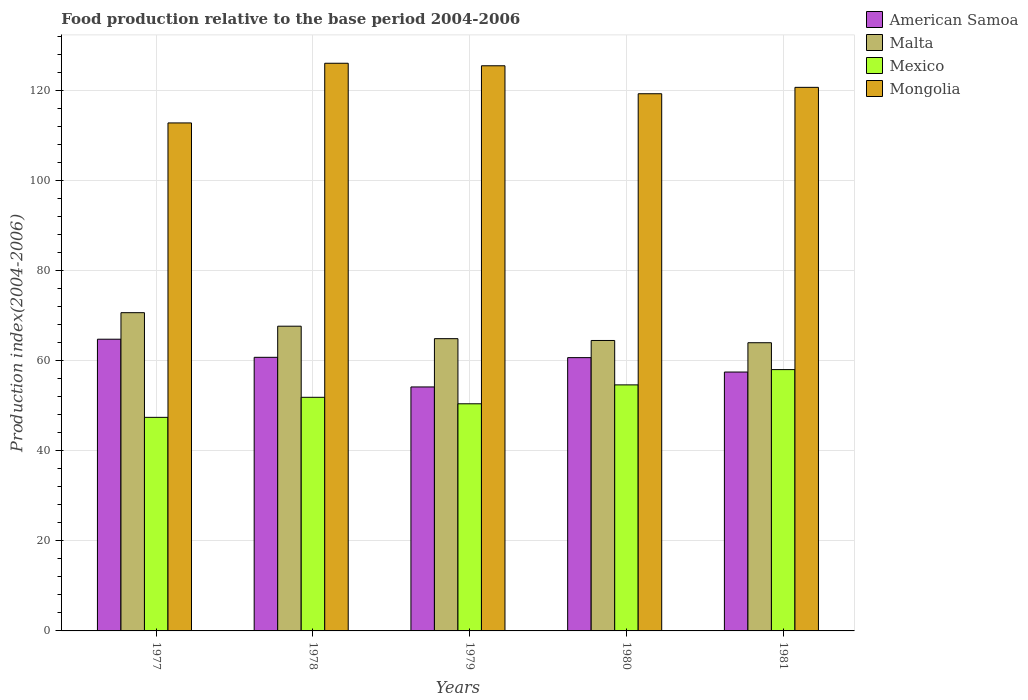How many different coloured bars are there?
Ensure brevity in your answer.  4. How many bars are there on the 2nd tick from the right?
Offer a very short reply. 4. In how many cases, is the number of bars for a given year not equal to the number of legend labels?
Ensure brevity in your answer.  0. What is the food production index in Mongolia in 1977?
Offer a terse response. 112.79. Across all years, what is the maximum food production index in Mexico?
Keep it short and to the point. 58.02. Across all years, what is the minimum food production index in Malta?
Provide a short and direct response. 63.99. In which year was the food production index in American Samoa maximum?
Your answer should be very brief. 1977. What is the total food production index in American Samoa in the graph?
Give a very brief answer. 297.85. What is the difference between the food production index in Mexico in 1977 and that in 1981?
Offer a terse response. -10.6. What is the difference between the food production index in Mexico in 1977 and the food production index in American Samoa in 1978?
Provide a succinct answer. -13.33. What is the average food production index in Mongolia per year?
Your answer should be compact. 120.85. In the year 1980, what is the difference between the food production index in Mexico and food production index in Malta?
Your answer should be compact. -9.86. What is the ratio of the food production index in American Samoa in 1979 to that in 1981?
Your response must be concise. 0.94. Is the difference between the food production index in Mexico in 1977 and 1980 greater than the difference between the food production index in Malta in 1977 and 1980?
Offer a terse response. No. What is the difference between the highest and the second highest food production index in American Samoa?
Your answer should be very brief. 4.02. What is the difference between the highest and the lowest food production index in Mexico?
Ensure brevity in your answer.  10.6. Is the sum of the food production index in Mongolia in 1978 and 1980 greater than the maximum food production index in American Samoa across all years?
Your response must be concise. Yes. Is it the case that in every year, the sum of the food production index in Mongolia and food production index in Mexico is greater than the sum of food production index in American Samoa and food production index in Malta?
Provide a succinct answer. Yes. What does the 1st bar from the left in 1980 represents?
Your response must be concise. American Samoa. What does the 4th bar from the right in 1979 represents?
Ensure brevity in your answer.  American Samoa. Is it the case that in every year, the sum of the food production index in American Samoa and food production index in Malta is greater than the food production index in Mongolia?
Ensure brevity in your answer.  No. How many bars are there?
Your response must be concise. 20. Are all the bars in the graph horizontal?
Provide a succinct answer. No. Are the values on the major ticks of Y-axis written in scientific E-notation?
Your answer should be compact. No. Does the graph contain grids?
Provide a short and direct response. Yes. Where does the legend appear in the graph?
Make the answer very short. Top right. How are the legend labels stacked?
Offer a very short reply. Vertical. What is the title of the graph?
Provide a succinct answer. Food production relative to the base period 2004-2006. What is the label or title of the Y-axis?
Give a very brief answer. Production index(2004-2006). What is the Production index(2004-2006) in American Samoa in 1977?
Make the answer very short. 64.77. What is the Production index(2004-2006) of Malta in 1977?
Provide a succinct answer. 70.66. What is the Production index(2004-2006) in Mexico in 1977?
Your response must be concise. 47.42. What is the Production index(2004-2006) of Mongolia in 1977?
Give a very brief answer. 112.79. What is the Production index(2004-2006) in American Samoa in 1978?
Your answer should be very brief. 60.75. What is the Production index(2004-2006) of Malta in 1978?
Your answer should be very brief. 67.66. What is the Production index(2004-2006) in Mexico in 1978?
Your answer should be compact. 51.87. What is the Production index(2004-2006) in Mongolia in 1978?
Offer a terse response. 126.04. What is the Production index(2004-2006) in American Samoa in 1979?
Your answer should be very brief. 54.17. What is the Production index(2004-2006) in Malta in 1979?
Keep it short and to the point. 64.89. What is the Production index(2004-2006) of Mexico in 1979?
Make the answer very short. 50.43. What is the Production index(2004-2006) of Mongolia in 1979?
Your answer should be very brief. 125.48. What is the Production index(2004-2006) in American Samoa in 1980?
Your response must be concise. 60.68. What is the Production index(2004-2006) in Malta in 1980?
Offer a terse response. 64.49. What is the Production index(2004-2006) in Mexico in 1980?
Your answer should be very brief. 54.63. What is the Production index(2004-2006) in Mongolia in 1980?
Offer a very short reply. 119.27. What is the Production index(2004-2006) of American Samoa in 1981?
Keep it short and to the point. 57.48. What is the Production index(2004-2006) of Malta in 1981?
Keep it short and to the point. 63.99. What is the Production index(2004-2006) in Mexico in 1981?
Offer a very short reply. 58.02. What is the Production index(2004-2006) in Mongolia in 1981?
Give a very brief answer. 120.69. Across all years, what is the maximum Production index(2004-2006) of American Samoa?
Your answer should be compact. 64.77. Across all years, what is the maximum Production index(2004-2006) of Malta?
Make the answer very short. 70.66. Across all years, what is the maximum Production index(2004-2006) of Mexico?
Make the answer very short. 58.02. Across all years, what is the maximum Production index(2004-2006) in Mongolia?
Provide a succinct answer. 126.04. Across all years, what is the minimum Production index(2004-2006) in American Samoa?
Your answer should be compact. 54.17. Across all years, what is the minimum Production index(2004-2006) in Malta?
Keep it short and to the point. 63.99. Across all years, what is the minimum Production index(2004-2006) of Mexico?
Offer a terse response. 47.42. Across all years, what is the minimum Production index(2004-2006) in Mongolia?
Give a very brief answer. 112.79. What is the total Production index(2004-2006) in American Samoa in the graph?
Ensure brevity in your answer.  297.85. What is the total Production index(2004-2006) of Malta in the graph?
Give a very brief answer. 331.69. What is the total Production index(2004-2006) of Mexico in the graph?
Your answer should be very brief. 262.37. What is the total Production index(2004-2006) of Mongolia in the graph?
Your answer should be compact. 604.27. What is the difference between the Production index(2004-2006) in American Samoa in 1977 and that in 1978?
Your answer should be compact. 4.02. What is the difference between the Production index(2004-2006) in Malta in 1977 and that in 1978?
Provide a succinct answer. 3. What is the difference between the Production index(2004-2006) in Mexico in 1977 and that in 1978?
Keep it short and to the point. -4.45. What is the difference between the Production index(2004-2006) in Mongolia in 1977 and that in 1978?
Your answer should be very brief. -13.25. What is the difference between the Production index(2004-2006) of Malta in 1977 and that in 1979?
Offer a very short reply. 5.77. What is the difference between the Production index(2004-2006) in Mexico in 1977 and that in 1979?
Your response must be concise. -3.01. What is the difference between the Production index(2004-2006) of Mongolia in 1977 and that in 1979?
Make the answer very short. -12.69. What is the difference between the Production index(2004-2006) of American Samoa in 1977 and that in 1980?
Give a very brief answer. 4.09. What is the difference between the Production index(2004-2006) in Malta in 1977 and that in 1980?
Offer a very short reply. 6.17. What is the difference between the Production index(2004-2006) in Mexico in 1977 and that in 1980?
Provide a succinct answer. -7.21. What is the difference between the Production index(2004-2006) of Mongolia in 1977 and that in 1980?
Ensure brevity in your answer.  -6.48. What is the difference between the Production index(2004-2006) of American Samoa in 1977 and that in 1981?
Offer a very short reply. 7.29. What is the difference between the Production index(2004-2006) in Malta in 1977 and that in 1981?
Ensure brevity in your answer.  6.67. What is the difference between the Production index(2004-2006) in Mongolia in 1977 and that in 1981?
Your answer should be compact. -7.9. What is the difference between the Production index(2004-2006) in American Samoa in 1978 and that in 1979?
Offer a terse response. 6.58. What is the difference between the Production index(2004-2006) of Malta in 1978 and that in 1979?
Give a very brief answer. 2.77. What is the difference between the Production index(2004-2006) in Mexico in 1978 and that in 1979?
Provide a short and direct response. 1.44. What is the difference between the Production index(2004-2006) of Mongolia in 1978 and that in 1979?
Provide a succinct answer. 0.56. What is the difference between the Production index(2004-2006) in American Samoa in 1978 and that in 1980?
Make the answer very short. 0.07. What is the difference between the Production index(2004-2006) in Malta in 1978 and that in 1980?
Ensure brevity in your answer.  3.17. What is the difference between the Production index(2004-2006) of Mexico in 1978 and that in 1980?
Provide a succinct answer. -2.76. What is the difference between the Production index(2004-2006) in Mongolia in 1978 and that in 1980?
Provide a succinct answer. 6.77. What is the difference between the Production index(2004-2006) of American Samoa in 1978 and that in 1981?
Keep it short and to the point. 3.27. What is the difference between the Production index(2004-2006) of Malta in 1978 and that in 1981?
Your answer should be compact. 3.67. What is the difference between the Production index(2004-2006) in Mexico in 1978 and that in 1981?
Offer a very short reply. -6.15. What is the difference between the Production index(2004-2006) in Mongolia in 1978 and that in 1981?
Make the answer very short. 5.35. What is the difference between the Production index(2004-2006) in American Samoa in 1979 and that in 1980?
Make the answer very short. -6.51. What is the difference between the Production index(2004-2006) in Malta in 1979 and that in 1980?
Offer a terse response. 0.4. What is the difference between the Production index(2004-2006) in Mongolia in 1979 and that in 1980?
Offer a terse response. 6.21. What is the difference between the Production index(2004-2006) of American Samoa in 1979 and that in 1981?
Make the answer very short. -3.31. What is the difference between the Production index(2004-2006) in Malta in 1979 and that in 1981?
Your answer should be very brief. 0.9. What is the difference between the Production index(2004-2006) in Mexico in 1979 and that in 1981?
Keep it short and to the point. -7.59. What is the difference between the Production index(2004-2006) of Mongolia in 1979 and that in 1981?
Ensure brevity in your answer.  4.79. What is the difference between the Production index(2004-2006) of Malta in 1980 and that in 1981?
Provide a short and direct response. 0.5. What is the difference between the Production index(2004-2006) of Mexico in 1980 and that in 1981?
Your answer should be very brief. -3.39. What is the difference between the Production index(2004-2006) of Mongolia in 1980 and that in 1981?
Offer a very short reply. -1.42. What is the difference between the Production index(2004-2006) in American Samoa in 1977 and the Production index(2004-2006) in Malta in 1978?
Provide a succinct answer. -2.89. What is the difference between the Production index(2004-2006) of American Samoa in 1977 and the Production index(2004-2006) of Mexico in 1978?
Offer a very short reply. 12.9. What is the difference between the Production index(2004-2006) of American Samoa in 1977 and the Production index(2004-2006) of Mongolia in 1978?
Keep it short and to the point. -61.27. What is the difference between the Production index(2004-2006) of Malta in 1977 and the Production index(2004-2006) of Mexico in 1978?
Provide a succinct answer. 18.79. What is the difference between the Production index(2004-2006) of Malta in 1977 and the Production index(2004-2006) of Mongolia in 1978?
Offer a terse response. -55.38. What is the difference between the Production index(2004-2006) of Mexico in 1977 and the Production index(2004-2006) of Mongolia in 1978?
Your answer should be very brief. -78.62. What is the difference between the Production index(2004-2006) of American Samoa in 1977 and the Production index(2004-2006) of Malta in 1979?
Provide a short and direct response. -0.12. What is the difference between the Production index(2004-2006) in American Samoa in 1977 and the Production index(2004-2006) in Mexico in 1979?
Provide a short and direct response. 14.34. What is the difference between the Production index(2004-2006) of American Samoa in 1977 and the Production index(2004-2006) of Mongolia in 1979?
Provide a short and direct response. -60.71. What is the difference between the Production index(2004-2006) of Malta in 1977 and the Production index(2004-2006) of Mexico in 1979?
Give a very brief answer. 20.23. What is the difference between the Production index(2004-2006) in Malta in 1977 and the Production index(2004-2006) in Mongolia in 1979?
Your answer should be very brief. -54.82. What is the difference between the Production index(2004-2006) of Mexico in 1977 and the Production index(2004-2006) of Mongolia in 1979?
Your answer should be very brief. -78.06. What is the difference between the Production index(2004-2006) of American Samoa in 1977 and the Production index(2004-2006) of Malta in 1980?
Give a very brief answer. 0.28. What is the difference between the Production index(2004-2006) in American Samoa in 1977 and the Production index(2004-2006) in Mexico in 1980?
Offer a terse response. 10.14. What is the difference between the Production index(2004-2006) in American Samoa in 1977 and the Production index(2004-2006) in Mongolia in 1980?
Your answer should be very brief. -54.5. What is the difference between the Production index(2004-2006) in Malta in 1977 and the Production index(2004-2006) in Mexico in 1980?
Make the answer very short. 16.03. What is the difference between the Production index(2004-2006) of Malta in 1977 and the Production index(2004-2006) of Mongolia in 1980?
Offer a terse response. -48.61. What is the difference between the Production index(2004-2006) in Mexico in 1977 and the Production index(2004-2006) in Mongolia in 1980?
Offer a terse response. -71.85. What is the difference between the Production index(2004-2006) of American Samoa in 1977 and the Production index(2004-2006) of Malta in 1981?
Ensure brevity in your answer.  0.78. What is the difference between the Production index(2004-2006) in American Samoa in 1977 and the Production index(2004-2006) in Mexico in 1981?
Your response must be concise. 6.75. What is the difference between the Production index(2004-2006) of American Samoa in 1977 and the Production index(2004-2006) of Mongolia in 1981?
Your answer should be very brief. -55.92. What is the difference between the Production index(2004-2006) of Malta in 1977 and the Production index(2004-2006) of Mexico in 1981?
Ensure brevity in your answer.  12.64. What is the difference between the Production index(2004-2006) in Malta in 1977 and the Production index(2004-2006) in Mongolia in 1981?
Provide a succinct answer. -50.03. What is the difference between the Production index(2004-2006) in Mexico in 1977 and the Production index(2004-2006) in Mongolia in 1981?
Provide a succinct answer. -73.27. What is the difference between the Production index(2004-2006) in American Samoa in 1978 and the Production index(2004-2006) in Malta in 1979?
Ensure brevity in your answer.  -4.14. What is the difference between the Production index(2004-2006) in American Samoa in 1978 and the Production index(2004-2006) in Mexico in 1979?
Offer a very short reply. 10.32. What is the difference between the Production index(2004-2006) of American Samoa in 1978 and the Production index(2004-2006) of Mongolia in 1979?
Offer a very short reply. -64.73. What is the difference between the Production index(2004-2006) of Malta in 1978 and the Production index(2004-2006) of Mexico in 1979?
Offer a very short reply. 17.23. What is the difference between the Production index(2004-2006) of Malta in 1978 and the Production index(2004-2006) of Mongolia in 1979?
Ensure brevity in your answer.  -57.82. What is the difference between the Production index(2004-2006) in Mexico in 1978 and the Production index(2004-2006) in Mongolia in 1979?
Provide a short and direct response. -73.61. What is the difference between the Production index(2004-2006) of American Samoa in 1978 and the Production index(2004-2006) of Malta in 1980?
Provide a short and direct response. -3.74. What is the difference between the Production index(2004-2006) of American Samoa in 1978 and the Production index(2004-2006) of Mexico in 1980?
Make the answer very short. 6.12. What is the difference between the Production index(2004-2006) in American Samoa in 1978 and the Production index(2004-2006) in Mongolia in 1980?
Offer a terse response. -58.52. What is the difference between the Production index(2004-2006) in Malta in 1978 and the Production index(2004-2006) in Mexico in 1980?
Give a very brief answer. 13.03. What is the difference between the Production index(2004-2006) in Malta in 1978 and the Production index(2004-2006) in Mongolia in 1980?
Your answer should be very brief. -51.61. What is the difference between the Production index(2004-2006) of Mexico in 1978 and the Production index(2004-2006) of Mongolia in 1980?
Provide a succinct answer. -67.4. What is the difference between the Production index(2004-2006) in American Samoa in 1978 and the Production index(2004-2006) in Malta in 1981?
Give a very brief answer. -3.24. What is the difference between the Production index(2004-2006) in American Samoa in 1978 and the Production index(2004-2006) in Mexico in 1981?
Keep it short and to the point. 2.73. What is the difference between the Production index(2004-2006) of American Samoa in 1978 and the Production index(2004-2006) of Mongolia in 1981?
Offer a very short reply. -59.94. What is the difference between the Production index(2004-2006) in Malta in 1978 and the Production index(2004-2006) in Mexico in 1981?
Offer a very short reply. 9.64. What is the difference between the Production index(2004-2006) of Malta in 1978 and the Production index(2004-2006) of Mongolia in 1981?
Your response must be concise. -53.03. What is the difference between the Production index(2004-2006) of Mexico in 1978 and the Production index(2004-2006) of Mongolia in 1981?
Offer a very short reply. -68.82. What is the difference between the Production index(2004-2006) in American Samoa in 1979 and the Production index(2004-2006) in Malta in 1980?
Your answer should be compact. -10.32. What is the difference between the Production index(2004-2006) in American Samoa in 1979 and the Production index(2004-2006) in Mexico in 1980?
Keep it short and to the point. -0.46. What is the difference between the Production index(2004-2006) of American Samoa in 1979 and the Production index(2004-2006) of Mongolia in 1980?
Your response must be concise. -65.1. What is the difference between the Production index(2004-2006) of Malta in 1979 and the Production index(2004-2006) of Mexico in 1980?
Your response must be concise. 10.26. What is the difference between the Production index(2004-2006) in Malta in 1979 and the Production index(2004-2006) in Mongolia in 1980?
Provide a short and direct response. -54.38. What is the difference between the Production index(2004-2006) of Mexico in 1979 and the Production index(2004-2006) of Mongolia in 1980?
Offer a very short reply. -68.84. What is the difference between the Production index(2004-2006) of American Samoa in 1979 and the Production index(2004-2006) of Malta in 1981?
Your response must be concise. -9.82. What is the difference between the Production index(2004-2006) in American Samoa in 1979 and the Production index(2004-2006) in Mexico in 1981?
Your answer should be very brief. -3.85. What is the difference between the Production index(2004-2006) in American Samoa in 1979 and the Production index(2004-2006) in Mongolia in 1981?
Give a very brief answer. -66.52. What is the difference between the Production index(2004-2006) in Malta in 1979 and the Production index(2004-2006) in Mexico in 1981?
Offer a terse response. 6.87. What is the difference between the Production index(2004-2006) in Malta in 1979 and the Production index(2004-2006) in Mongolia in 1981?
Provide a short and direct response. -55.8. What is the difference between the Production index(2004-2006) of Mexico in 1979 and the Production index(2004-2006) of Mongolia in 1981?
Offer a very short reply. -70.26. What is the difference between the Production index(2004-2006) of American Samoa in 1980 and the Production index(2004-2006) of Malta in 1981?
Provide a short and direct response. -3.31. What is the difference between the Production index(2004-2006) of American Samoa in 1980 and the Production index(2004-2006) of Mexico in 1981?
Make the answer very short. 2.66. What is the difference between the Production index(2004-2006) of American Samoa in 1980 and the Production index(2004-2006) of Mongolia in 1981?
Ensure brevity in your answer.  -60.01. What is the difference between the Production index(2004-2006) in Malta in 1980 and the Production index(2004-2006) in Mexico in 1981?
Your answer should be very brief. 6.47. What is the difference between the Production index(2004-2006) of Malta in 1980 and the Production index(2004-2006) of Mongolia in 1981?
Ensure brevity in your answer.  -56.2. What is the difference between the Production index(2004-2006) in Mexico in 1980 and the Production index(2004-2006) in Mongolia in 1981?
Make the answer very short. -66.06. What is the average Production index(2004-2006) of American Samoa per year?
Make the answer very short. 59.57. What is the average Production index(2004-2006) of Malta per year?
Your answer should be compact. 66.34. What is the average Production index(2004-2006) in Mexico per year?
Ensure brevity in your answer.  52.47. What is the average Production index(2004-2006) in Mongolia per year?
Keep it short and to the point. 120.85. In the year 1977, what is the difference between the Production index(2004-2006) in American Samoa and Production index(2004-2006) in Malta?
Your answer should be very brief. -5.89. In the year 1977, what is the difference between the Production index(2004-2006) in American Samoa and Production index(2004-2006) in Mexico?
Ensure brevity in your answer.  17.35. In the year 1977, what is the difference between the Production index(2004-2006) in American Samoa and Production index(2004-2006) in Mongolia?
Your response must be concise. -48.02. In the year 1977, what is the difference between the Production index(2004-2006) in Malta and Production index(2004-2006) in Mexico?
Offer a terse response. 23.24. In the year 1977, what is the difference between the Production index(2004-2006) in Malta and Production index(2004-2006) in Mongolia?
Provide a succinct answer. -42.13. In the year 1977, what is the difference between the Production index(2004-2006) of Mexico and Production index(2004-2006) of Mongolia?
Keep it short and to the point. -65.37. In the year 1978, what is the difference between the Production index(2004-2006) of American Samoa and Production index(2004-2006) of Malta?
Provide a succinct answer. -6.91. In the year 1978, what is the difference between the Production index(2004-2006) in American Samoa and Production index(2004-2006) in Mexico?
Your response must be concise. 8.88. In the year 1978, what is the difference between the Production index(2004-2006) in American Samoa and Production index(2004-2006) in Mongolia?
Ensure brevity in your answer.  -65.29. In the year 1978, what is the difference between the Production index(2004-2006) of Malta and Production index(2004-2006) of Mexico?
Offer a very short reply. 15.79. In the year 1978, what is the difference between the Production index(2004-2006) of Malta and Production index(2004-2006) of Mongolia?
Ensure brevity in your answer.  -58.38. In the year 1978, what is the difference between the Production index(2004-2006) of Mexico and Production index(2004-2006) of Mongolia?
Give a very brief answer. -74.17. In the year 1979, what is the difference between the Production index(2004-2006) of American Samoa and Production index(2004-2006) of Malta?
Your answer should be very brief. -10.72. In the year 1979, what is the difference between the Production index(2004-2006) in American Samoa and Production index(2004-2006) in Mexico?
Your answer should be very brief. 3.74. In the year 1979, what is the difference between the Production index(2004-2006) in American Samoa and Production index(2004-2006) in Mongolia?
Your answer should be very brief. -71.31. In the year 1979, what is the difference between the Production index(2004-2006) of Malta and Production index(2004-2006) of Mexico?
Ensure brevity in your answer.  14.46. In the year 1979, what is the difference between the Production index(2004-2006) of Malta and Production index(2004-2006) of Mongolia?
Make the answer very short. -60.59. In the year 1979, what is the difference between the Production index(2004-2006) in Mexico and Production index(2004-2006) in Mongolia?
Make the answer very short. -75.05. In the year 1980, what is the difference between the Production index(2004-2006) in American Samoa and Production index(2004-2006) in Malta?
Offer a very short reply. -3.81. In the year 1980, what is the difference between the Production index(2004-2006) of American Samoa and Production index(2004-2006) of Mexico?
Offer a very short reply. 6.05. In the year 1980, what is the difference between the Production index(2004-2006) in American Samoa and Production index(2004-2006) in Mongolia?
Provide a succinct answer. -58.59. In the year 1980, what is the difference between the Production index(2004-2006) of Malta and Production index(2004-2006) of Mexico?
Provide a succinct answer. 9.86. In the year 1980, what is the difference between the Production index(2004-2006) of Malta and Production index(2004-2006) of Mongolia?
Your response must be concise. -54.78. In the year 1980, what is the difference between the Production index(2004-2006) in Mexico and Production index(2004-2006) in Mongolia?
Provide a succinct answer. -64.64. In the year 1981, what is the difference between the Production index(2004-2006) in American Samoa and Production index(2004-2006) in Malta?
Offer a very short reply. -6.51. In the year 1981, what is the difference between the Production index(2004-2006) of American Samoa and Production index(2004-2006) of Mexico?
Keep it short and to the point. -0.54. In the year 1981, what is the difference between the Production index(2004-2006) of American Samoa and Production index(2004-2006) of Mongolia?
Make the answer very short. -63.21. In the year 1981, what is the difference between the Production index(2004-2006) in Malta and Production index(2004-2006) in Mexico?
Your response must be concise. 5.97. In the year 1981, what is the difference between the Production index(2004-2006) of Malta and Production index(2004-2006) of Mongolia?
Offer a very short reply. -56.7. In the year 1981, what is the difference between the Production index(2004-2006) in Mexico and Production index(2004-2006) in Mongolia?
Ensure brevity in your answer.  -62.67. What is the ratio of the Production index(2004-2006) of American Samoa in 1977 to that in 1978?
Offer a terse response. 1.07. What is the ratio of the Production index(2004-2006) of Malta in 1977 to that in 1978?
Offer a very short reply. 1.04. What is the ratio of the Production index(2004-2006) of Mexico in 1977 to that in 1978?
Provide a succinct answer. 0.91. What is the ratio of the Production index(2004-2006) in Mongolia in 1977 to that in 1978?
Keep it short and to the point. 0.89. What is the ratio of the Production index(2004-2006) in American Samoa in 1977 to that in 1979?
Provide a short and direct response. 1.2. What is the ratio of the Production index(2004-2006) in Malta in 1977 to that in 1979?
Ensure brevity in your answer.  1.09. What is the ratio of the Production index(2004-2006) in Mexico in 1977 to that in 1979?
Give a very brief answer. 0.94. What is the ratio of the Production index(2004-2006) in Mongolia in 1977 to that in 1979?
Offer a very short reply. 0.9. What is the ratio of the Production index(2004-2006) in American Samoa in 1977 to that in 1980?
Your answer should be very brief. 1.07. What is the ratio of the Production index(2004-2006) of Malta in 1977 to that in 1980?
Offer a very short reply. 1.1. What is the ratio of the Production index(2004-2006) of Mexico in 1977 to that in 1980?
Make the answer very short. 0.87. What is the ratio of the Production index(2004-2006) of Mongolia in 1977 to that in 1980?
Keep it short and to the point. 0.95. What is the ratio of the Production index(2004-2006) of American Samoa in 1977 to that in 1981?
Ensure brevity in your answer.  1.13. What is the ratio of the Production index(2004-2006) in Malta in 1977 to that in 1981?
Your answer should be very brief. 1.1. What is the ratio of the Production index(2004-2006) in Mexico in 1977 to that in 1981?
Provide a succinct answer. 0.82. What is the ratio of the Production index(2004-2006) in Mongolia in 1977 to that in 1981?
Your response must be concise. 0.93. What is the ratio of the Production index(2004-2006) of American Samoa in 1978 to that in 1979?
Provide a succinct answer. 1.12. What is the ratio of the Production index(2004-2006) in Malta in 1978 to that in 1979?
Your answer should be compact. 1.04. What is the ratio of the Production index(2004-2006) in Mexico in 1978 to that in 1979?
Your answer should be very brief. 1.03. What is the ratio of the Production index(2004-2006) of Mongolia in 1978 to that in 1979?
Your answer should be very brief. 1. What is the ratio of the Production index(2004-2006) in Malta in 1978 to that in 1980?
Your answer should be very brief. 1.05. What is the ratio of the Production index(2004-2006) in Mexico in 1978 to that in 1980?
Give a very brief answer. 0.95. What is the ratio of the Production index(2004-2006) of Mongolia in 1978 to that in 1980?
Your answer should be very brief. 1.06. What is the ratio of the Production index(2004-2006) of American Samoa in 1978 to that in 1981?
Your answer should be compact. 1.06. What is the ratio of the Production index(2004-2006) of Malta in 1978 to that in 1981?
Your answer should be compact. 1.06. What is the ratio of the Production index(2004-2006) in Mexico in 1978 to that in 1981?
Offer a very short reply. 0.89. What is the ratio of the Production index(2004-2006) in Mongolia in 1978 to that in 1981?
Give a very brief answer. 1.04. What is the ratio of the Production index(2004-2006) in American Samoa in 1979 to that in 1980?
Your answer should be very brief. 0.89. What is the ratio of the Production index(2004-2006) in Mongolia in 1979 to that in 1980?
Your response must be concise. 1.05. What is the ratio of the Production index(2004-2006) in American Samoa in 1979 to that in 1981?
Give a very brief answer. 0.94. What is the ratio of the Production index(2004-2006) in Malta in 1979 to that in 1981?
Your response must be concise. 1.01. What is the ratio of the Production index(2004-2006) in Mexico in 1979 to that in 1981?
Ensure brevity in your answer.  0.87. What is the ratio of the Production index(2004-2006) of Mongolia in 1979 to that in 1981?
Provide a succinct answer. 1.04. What is the ratio of the Production index(2004-2006) of American Samoa in 1980 to that in 1981?
Make the answer very short. 1.06. What is the ratio of the Production index(2004-2006) in Malta in 1980 to that in 1981?
Provide a short and direct response. 1.01. What is the ratio of the Production index(2004-2006) in Mexico in 1980 to that in 1981?
Keep it short and to the point. 0.94. What is the ratio of the Production index(2004-2006) of Mongolia in 1980 to that in 1981?
Your answer should be very brief. 0.99. What is the difference between the highest and the second highest Production index(2004-2006) in American Samoa?
Offer a terse response. 4.02. What is the difference between the highest and the second highest Production index(2004-2006) of Mexico?
Offer a terse response. 3.39. What is the difference between the highest and the second highest Production index(2004-2006) of Mongolia?
Your answer should be compact. 0.56. What is the difference between the highest and the lowest Production index(2004-2006) in Malta?
Your response must be concise. 6.67. What is the difference between the highest and the lowest Production index(2004-2006) of Mexico?
Ensure brevity in your answer.  10.6. What is the difference between the highest and the lowest Production index(2004-2006) of Mongolia?
Offer a terse response. 13.25. 